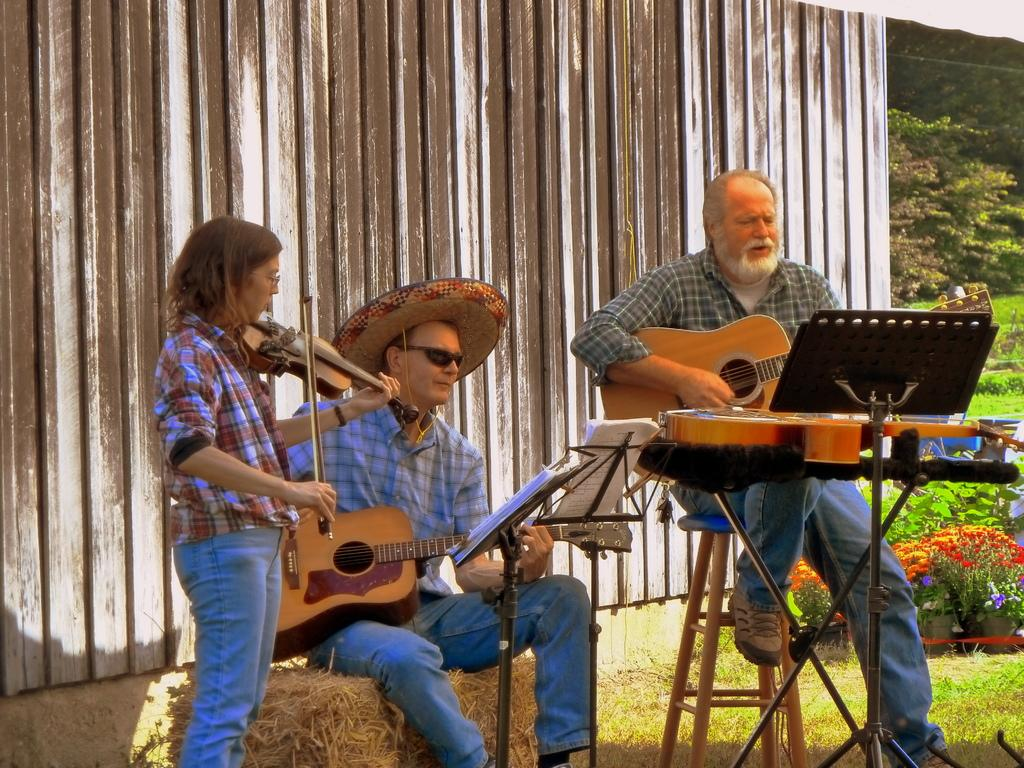How many people are in the image? There are two men and a woman in the image. What is one of the men doing in the image? One man is holding a guitar and playing it. What is the woman doing in the image? The woman is playing a musical instrument. What can be seen in the background of the image? There is a shed and a tree in the background of the image. What type of trouble can be seen in the image? There is no trouble depicted in the image; it features two men and a woman playing musical instruments. What kind of shop is visible in the image? There is no shop present in the image; it features a shed and a tree in the background. 